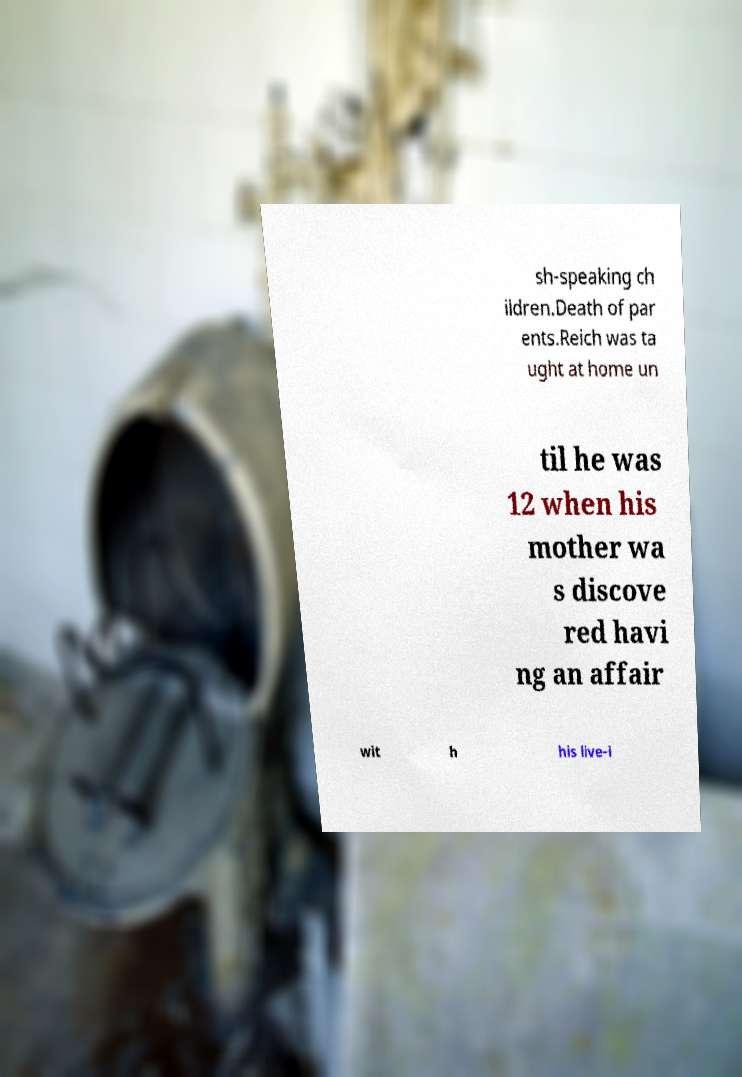Can you read and provide the text displayed in the image?This photo seems to have some interesting text. Can you extract and type it out for me? sh-speaking ch ildren.Death of par ents.Reich was ta ught at home un til he was 12 when his mother wa s discove red havi ng an affair wit h his live-i 